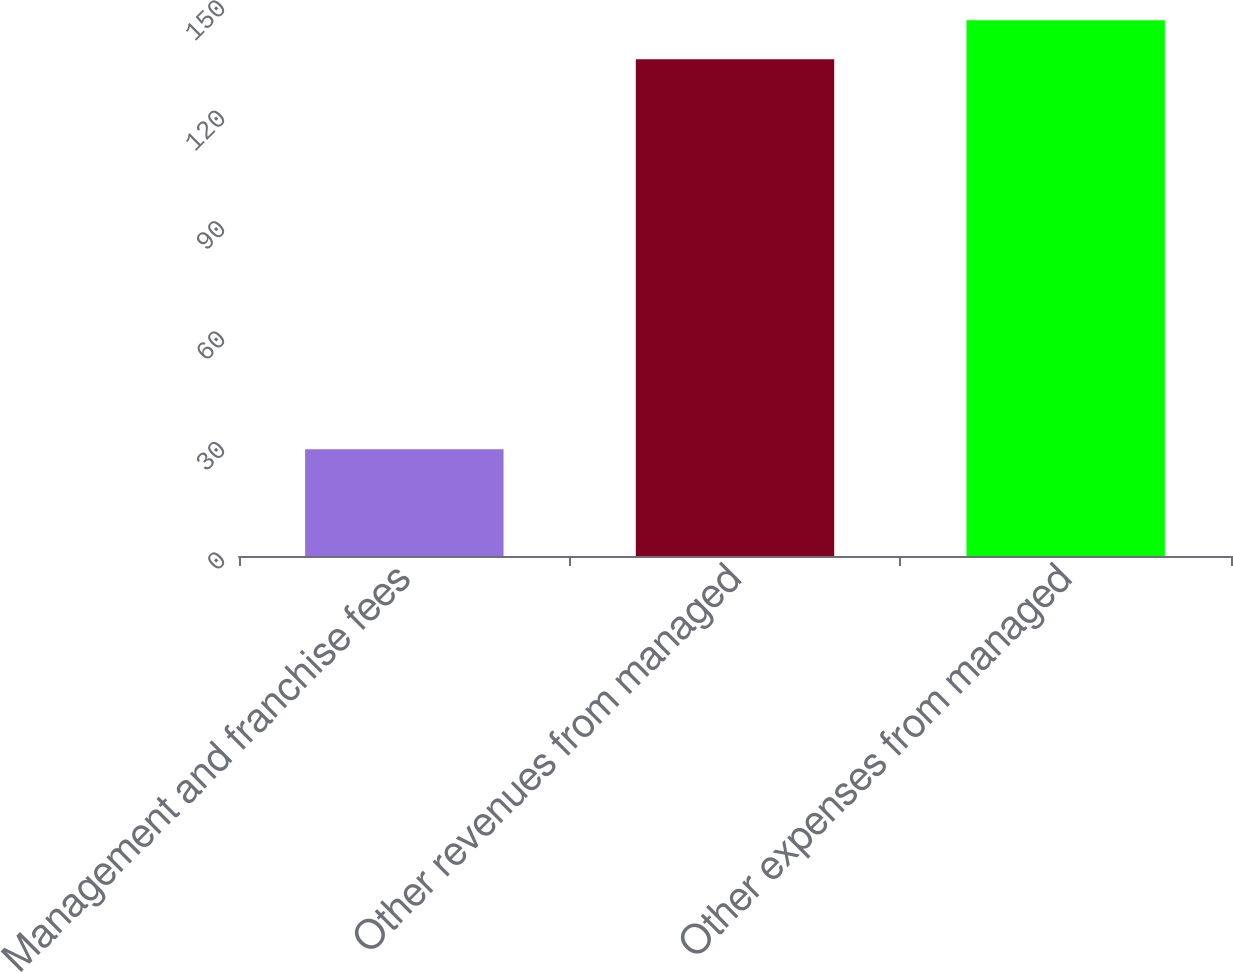<chart> <loc_0><loc_0><loc_500><loc_500><bar_chart><fcel>Management and franchise fees<fcel>Other revenues from managed<fcel>Other expenses from managed<nl><fcel>29<fcel>135<fcel>145.6<nl></chart> 